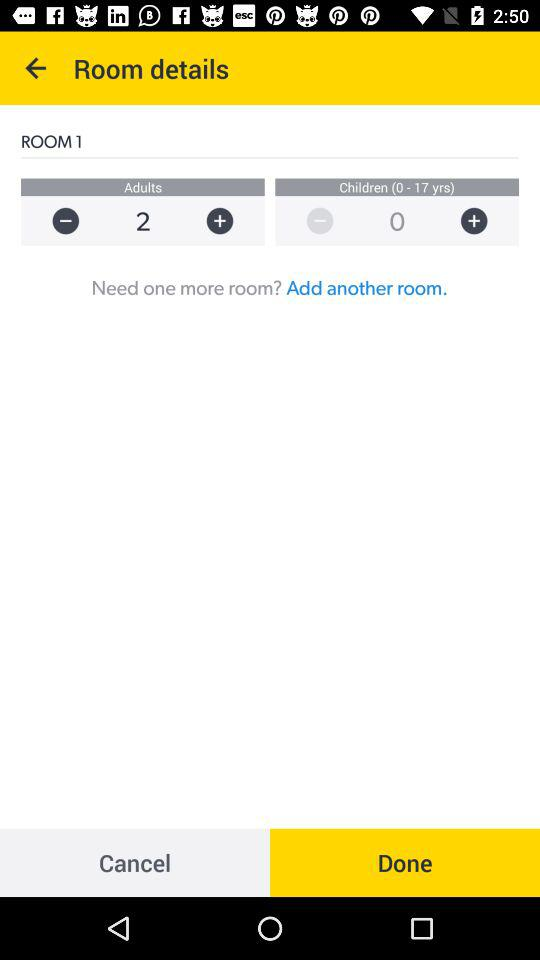What is the total number of children in room number 1? The total number of children is 0. 